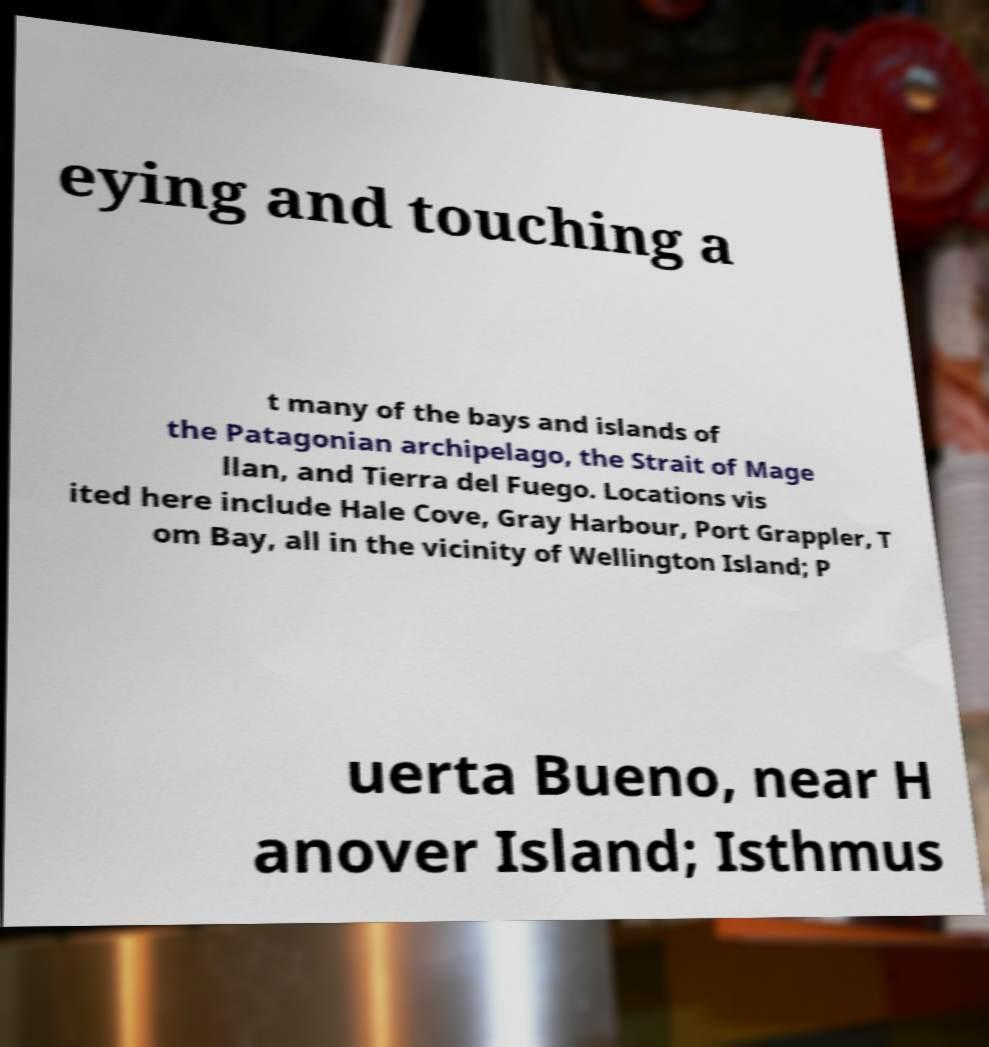What messages or text are displayed in this image? I need them in a readable, typed format. eying and touching a t many of the bays and islands of the Patagonian archipelago, the Strait of Mage llan, and Tierra del Fuego. Locations vis ited here include Hale Cove, Gray Harbour, Port Grappler, T om Bay, all in the vicinity of Wellington Island; P uerta Bueno, near H anover Island; Isthmus 